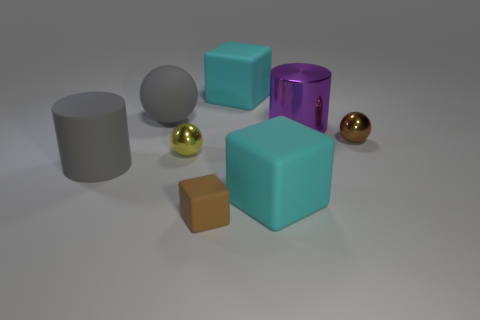Subtract all big blocks. How many blocks are left? 1 Subtract all gray cylinders. How many cylinders are left? 1 Add 1 cyan rubber things. How many objects exist? 9 Subtract 1 cylinders. How many cylinders are left? 1 Subtract all cylinders. How many objects are left? 6 Add 2 big purple metallic cylinders. How many big purple metallic cylinders exist? 3 Subtract 0 green balls. How many objects are left? 8 Subtract all blue balls. Subtract all red blocks. How many balls are left? 3 Subtract all blue cylinders. How many brown blocks are left? 1 Subtract all small purple shiny spheres. Subtract all small brown matte cubes. How many objects are left? 7 